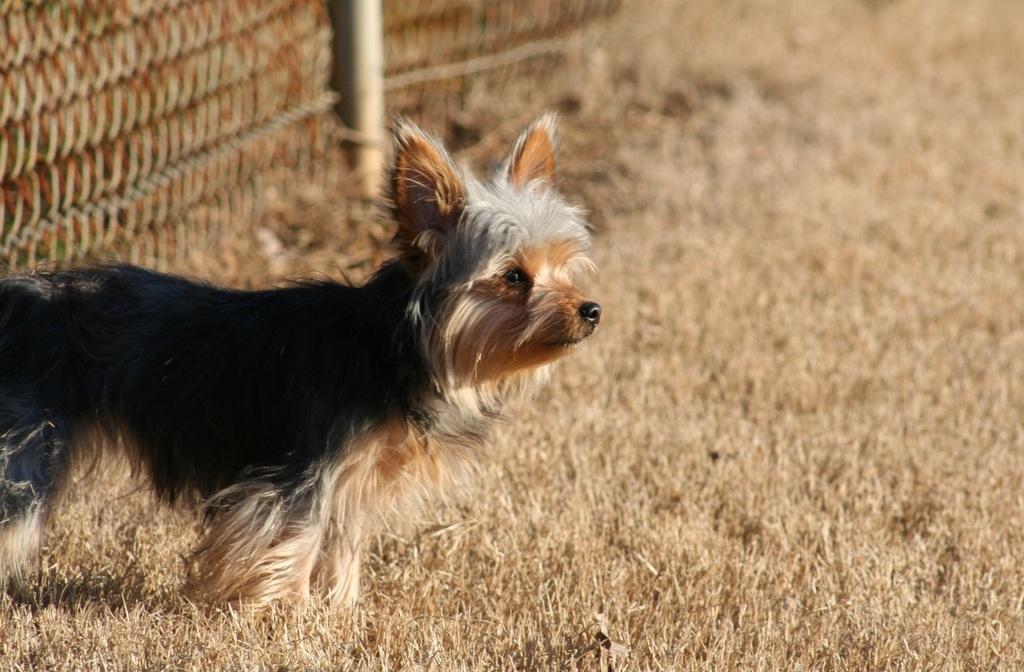In one or two sentences, can you explain what this image depicts? In this image there is the grass, there is a dog, there is a fencing towards the top of the image. 